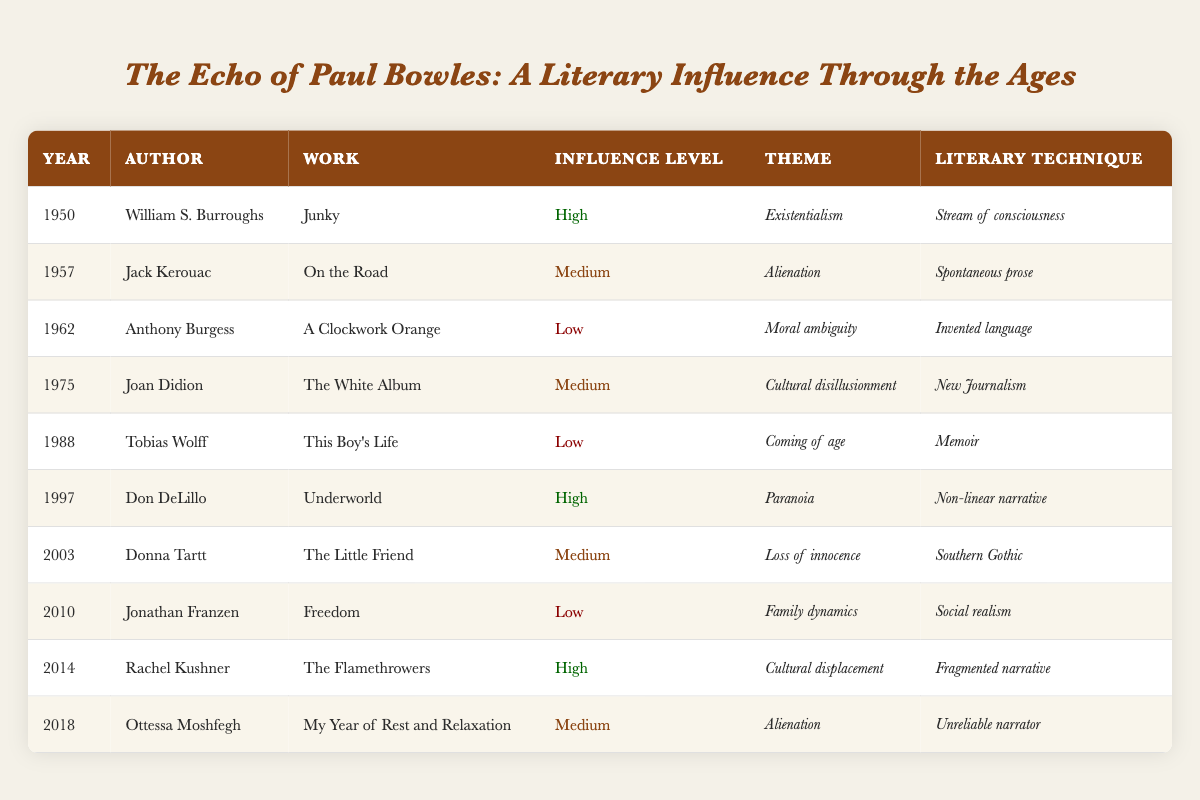What is the most recent work influenced by Paul Bowles? The most recent work listed in the table is "My Year of Rest and Relaxation" by Ottessa Moshfegh from the year 2018.
Answer: My Year of Rest and Relaxation Which author had a high influence level in 1997? The author with a high influence level in 1997 is Don DeLillo, who wrote "Underworld."
Answer: Don DeLillo How many works are categorized with a low influence level? There are three works with a low influence level: "A Clockwork Orange" by Anthony Burgess, "This Boy's Life" by Tobias Wolff, and "Freedom" by Jonathan Franzen, making a total of three.
Answer: 3 Was there any author who exhibited a high influence level in the 1950s? Yes, William S. Burroughs exhibited a high influence level in 1950 with his work "Junky."
Answer: Yes What is the average influence level over the years presented? The influence levels can be categorized numerically as follows: High = 5, Medium = 4, Low = 3. To compute the average, (5 + 4 + 3) / 3 = 12 / 3 = 4 (when we account for their counts). The average influence level is thus medium, as there are more medium levels than low.
Answer: Medium Which literary techniques were used in works influenced by Paul Bowles that are categorized as high influence? The literary techniques for high influence works are: "Stream of consciousness" by William S. Burroughs, "Non-linear narrative" by Don DeLillo, and "Fragmented narrative" by Rachel Kushner.
Answer: Stream of consciousness, Non-linear narrative, Fragmented narrative Identify the themes associated with authors who had medium influence levels. The themes associated with medium influence levels are: "Alienation" (Jack Kerouac and Ottessa Moshfegh), "Cultural disillusionment" (Joan Didion), and "Loss of innocence" (Donna Tartt), totaling three unique themes.
Answer: Alienation, Cultural disillusionment, Loss of innocence Which year saw the highest number of medium influence level works, and how many were there? The year 2014 saw the highest number of medium influence level works, with a total of three: Joan Didion's "The White Album," Donna Tartt's "The Little Friend," and Ottessa Moshfegh's "My Year of Rest and Relaxation."
Answer: 2014, 3 How many authors were influenced by Paul Bowles between 1950 and 1980? The table lists authors influenced by Paul Bowles from 1950 to 1980 as follows: William S. Burroughs (1950), Jack Kerouac (1957), Anthony Burgess (1962), and Joan Didion (1975), totaling four authors in that time frame.
Answer: 4 